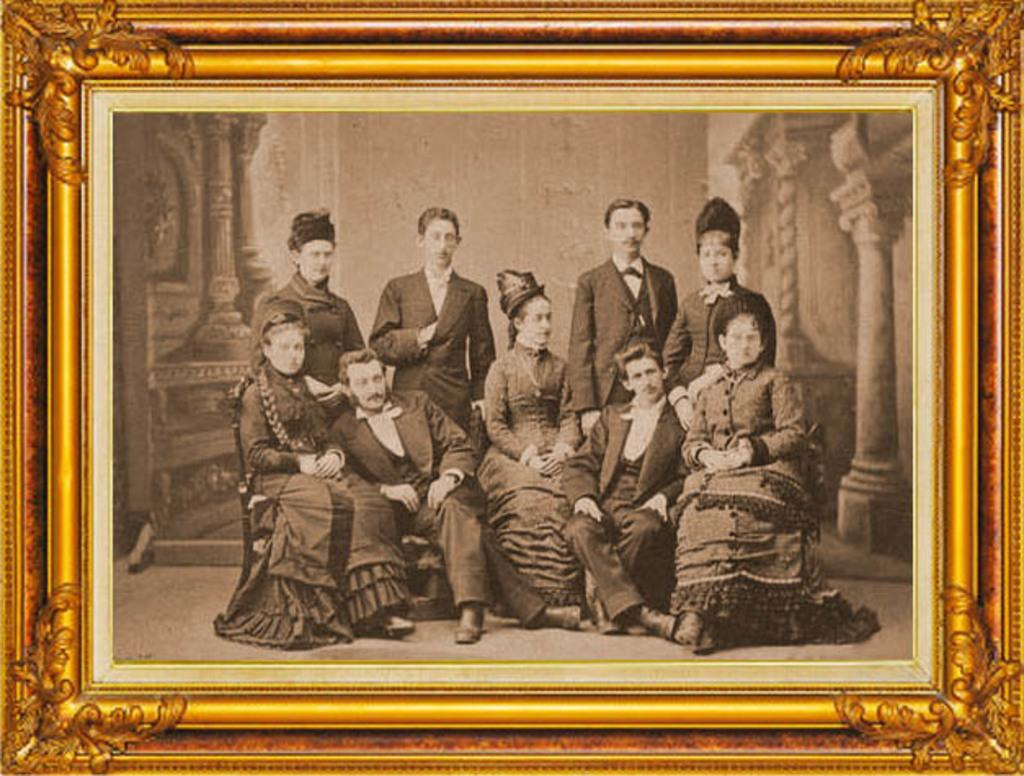Who or what can be seen in the image? There are people in the image. Can you describe the setting or context of the image? The people are within a frame, which suggests they are being photographed or displayed in some way. What type of riddle can be solved by looking at the image? There is no riddle present in the image, so it cannot be solved by looking at it. 